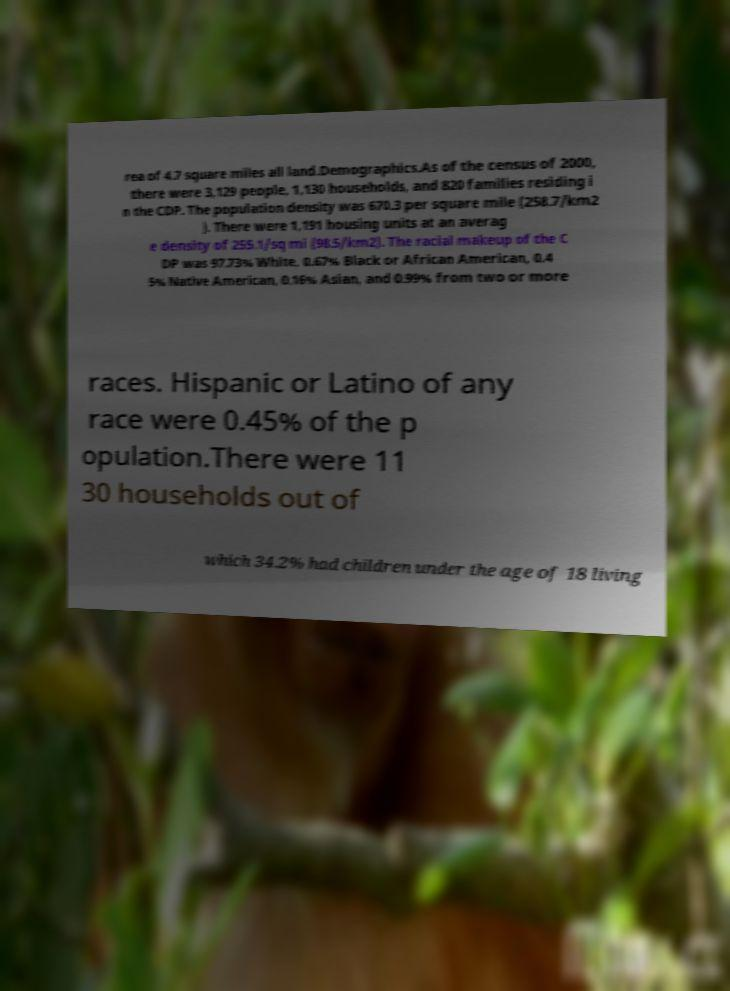There's text embedded in this image that I need extracted. Can you transcribe it verbatim? rea of 4.7 square miles all land.Demographics.As of the census of 2000, there were 3,129 people, 1,130 households, and 820 families residing i n the CDP. The population density was 670.3 per square mile (258.7/km2 ). There were 1,191 housing units at an averag e density of 255.1/sq mi (98.5/km2). The racial makeup of the C DP was 97.73% White, 0.67% Black or African American, 0.4 5% Native American, 0.16% Asian, and 0.99% from two or more races. Hispanic or Latino of any race were 0.45% of the p opulation.There were 11 30 households out of which 34.2% had children under the age of 18 living 